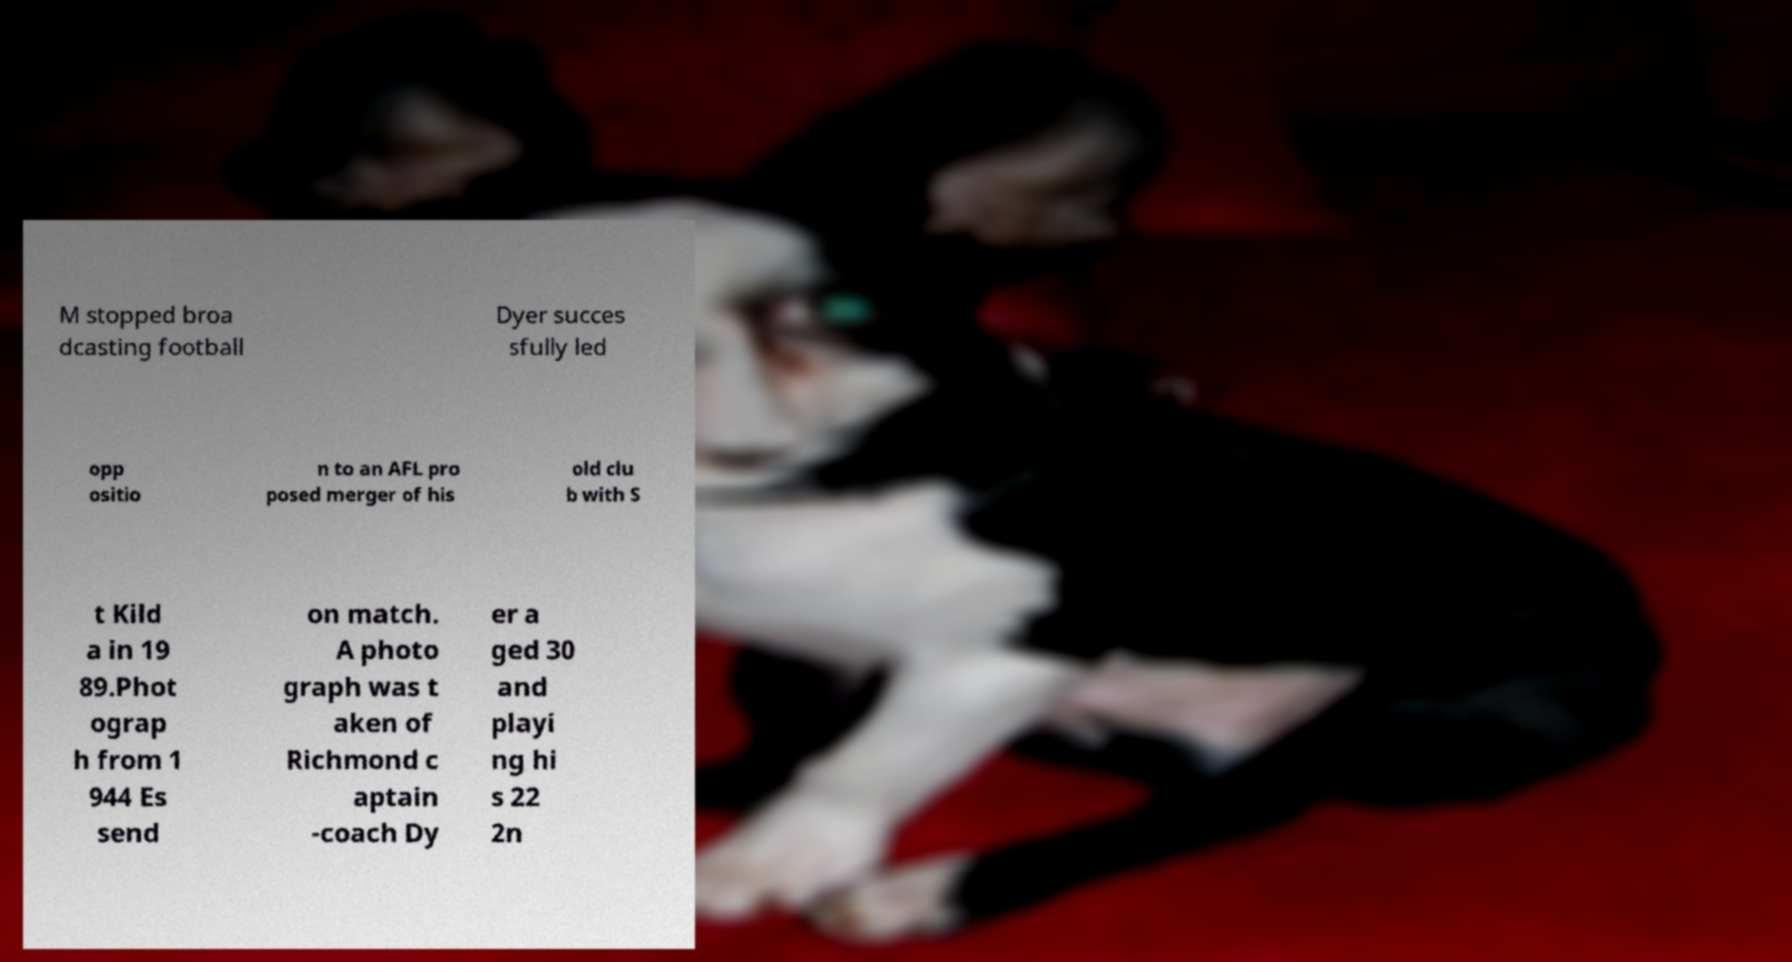Please read and relay the text visible in this image. What does it say? M stopped broa dcasting football Dyer succes sfully led opp ositio n to an AFL pro posed merger of his old clu b with S t Kild a in 19 89.Phot ograp h from 1 944 Es send on match. A photo graph was t aken of Richmond c aptain -coach Dy er a ged 30 and playi ng hi s 22 2n 